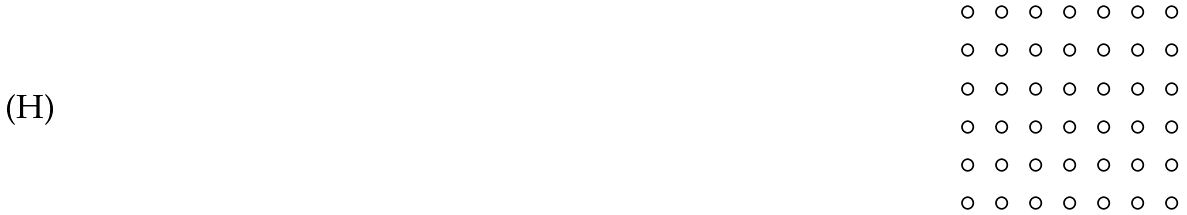Convert formula to latex. <formula><loc_0><loc_0><loc_500><loc_500>\begin{matrix} \circ & \circ & \circ & \circ & \circ & \circ & \circ \\ \circ & \circ & \circ & \circ & \circ & \circ & \circ \\ \circ & \circ & \circ & \circ & \circ & \circ & \circ \\ \circ & \circ & \circ & \circ & \circ & \circ & \circ \\ \circ & \circ & \circ & \circ & \circ & \circ & \circ \\ \circ & \circ & \circ & \circ & \circ & \circ & \circ \end{matrix}</formula> 